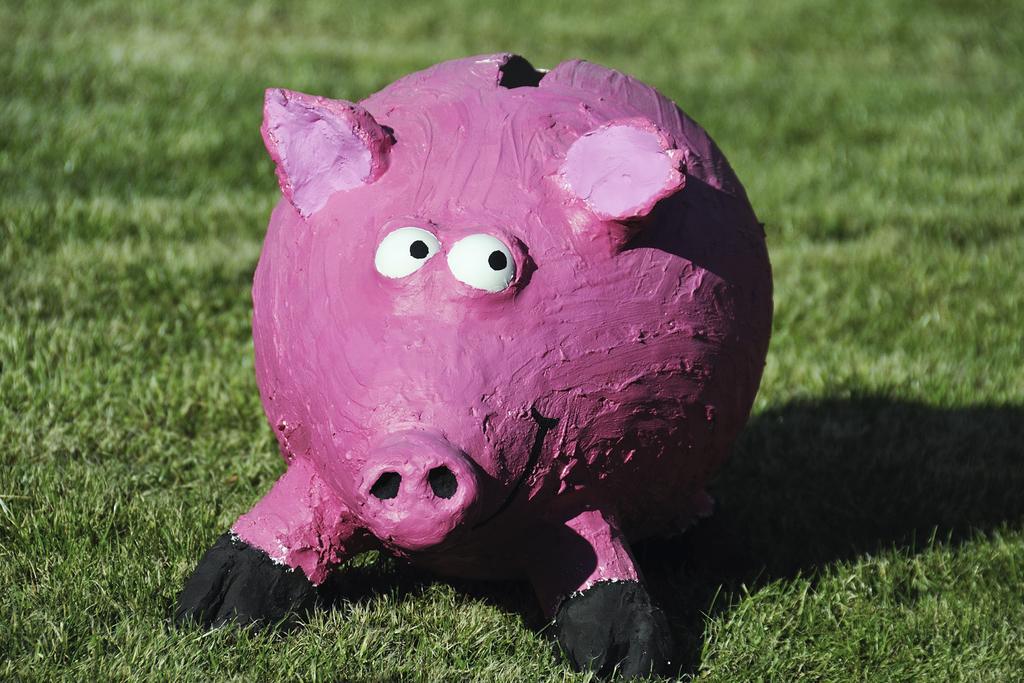How would you summarize this image in a sentence or two? In this image we can see a pig coin bank on the grass on the ground. 